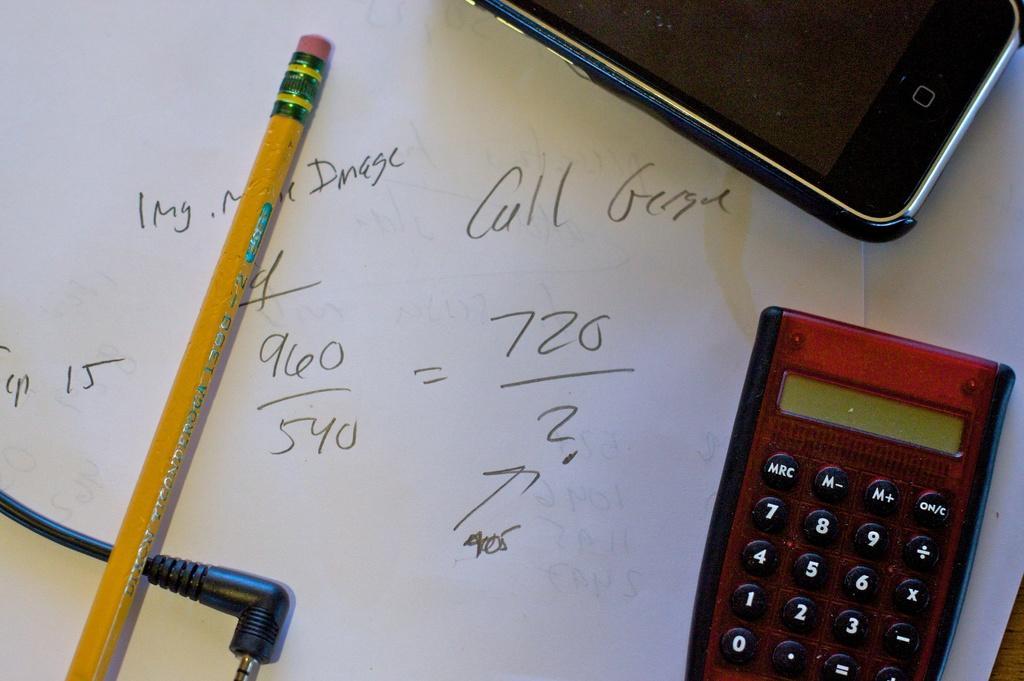In one or two sentences, can you explain what this image depicts? In the given image i can see a pencil,paper,wire,mobile phone and calculator. 